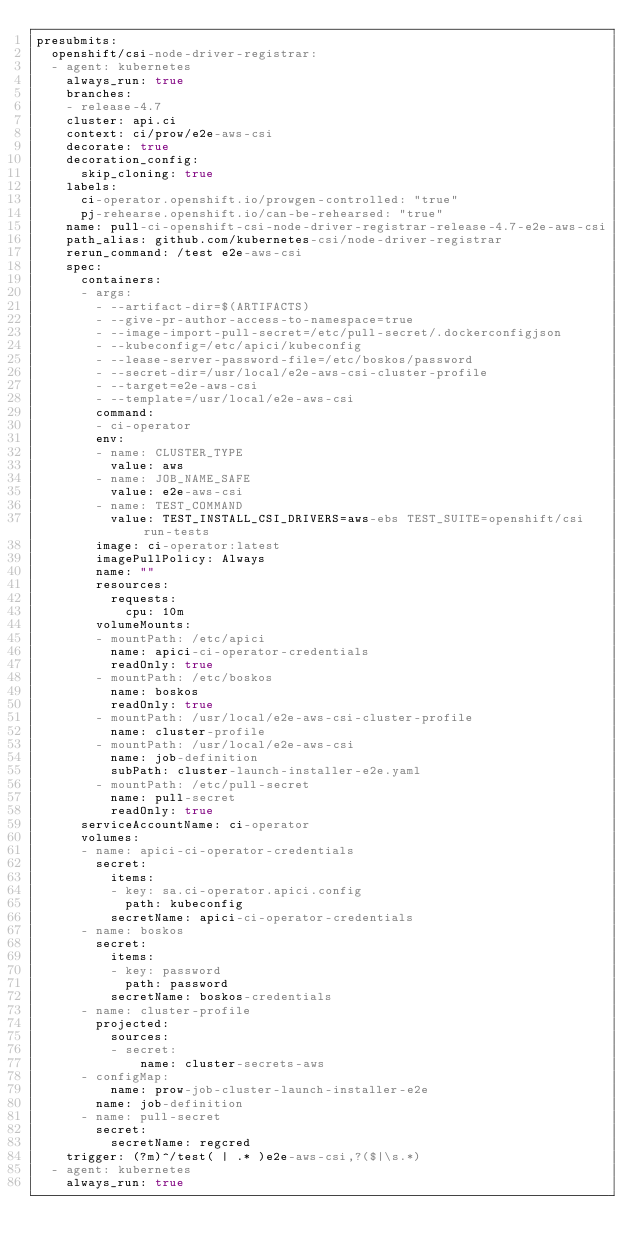<code> <loc_0><loc_0><loc_500><loc_500><_YAML_>presubmits:
  openshift/csi-node-driver-registrar:
  - agent: kubernetes
    always_run: true
    branches:
    - release-4.7
    cluster: api.ci
    context: ci/prow/e2e-aws-csi
    decorate: true
    decoration_config:
      skip_cloning: true
    labels:
      ci-operator.openshift.io/prowgen-controlled: "true"
      pj-rehearse.openshift.io/can-be-rehearsed: "true"
    name: pull-ci-openshift-csi-node-driver-registrar-release-4.7-e2e-aws-csi
    path_alias: github.com/kubernetes-csi/node-driver-registrar
    rerun_command: /test e2e-aws-csi
    spec:
      containers:
      - args:
        - --artifact-dir=$(ARTIFACTS)
        - --give-pr-author-access-to-namespace=true
        - --image-import-pull-secret=/etc/pull-secret/.dockerconfigjson
        - --kubeconfig=/etc/apici/kubeconfig
        - --lease-server-password-file=/etc/boskos/password
        - --secret-dir=/usr/local/e2e-aws-csi-cluster-profile
        - --target=e2e-aws-csi
        - --template=/usr/local/e2e-aws-csi
        command:
        - ci-operator
        env:
        - name: CLUSTER_TYPE
          value: aws
        - name: JOB_NAME_SAFE
          value: e2e-aws-csi
        - name: TEST_COMMAND
          value: TEST_INSTALL_CSI_DRIVERS=aws-ebs TEST_SUITE=openshift/csi run-tests
        image: ci-operator:latest
        imagePullPolicy: Always
        name: ""
        resources:
          requests:
            cpu: 10m
        volumeMounts:
        - mountPath: /etc/apici
          name: apici-ci-operator-credentials
          readOnly: true
        - mountPath: /etc/boskos
          name: boskos
          readOnly: true
        - mountPath: /usr/local/e2e-aws-csi-cluster-profile
          name: cluster-profile
        - mountPath: /usr/local/e2e-aws-csi
          name: job-definition
          subPath: cluster-launch-installer-e2e.yaml
        - mountPath: /etc/pull-secret
          name: pull-secret
          readOnly: true
      serviceAccountName: ci-operator
      volumes:
      - name: apici-ci-operator-credentials
        secret:
          items:
          - key: sa.ci-operator.apici.config
            path: kubeconfig
          secretName: apici-ci-operator-credentials
      - name: boskos
        secret:
          items:
          - key: password
            path: password
          secretName: boskos-credentials
      - name: cluster-profile
        projected:
          sources:
          - secret:
              name: cluster-secrets-aws
      - configMap:
          name: prow-job-cluster-launch-installer-e2e
        name: job-definition
      - name: pull-secret
        secret:
          secretName: regcred
    trigger: (?m)^/test( | .* )e2e-aws-csi,?($|\s.*)
  - agent: kubernetes
    always_run: true</code> 